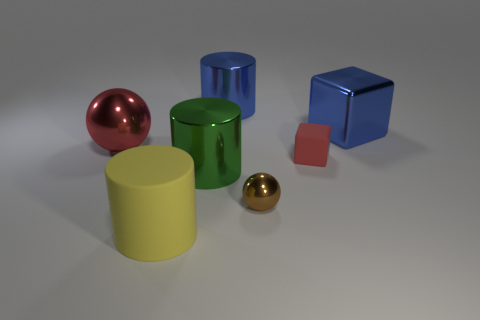What size is the other thing that is the same material as the tiny red thing?
Your answer should be compact. Large. What number of brown shiny things are the same shape as the large green thing?
Your answer should be very brief. 0. What number of red things are there?
Provide a succinct answer. 2. There is a red thing in front of the big metallic ball; is it the same shape as the large green thing?
Your answer should be very brief. No. Are there the same number of shiny blocks and large yellow metallic cylinders?
Make the answer very short. No. What is the material of the red sphere that is the same size as the blue block?
Keep it short and to the point. Metal. Are there any large gray blocks made of the same material as the tiny ball?
Provide a short and direct response. No. Do the tiny brown metallic thing and the green object that is in front of the red ball have the same shape?
Your response must be concise. No. How many metallic things are on the right side of the large green cylinder and on the left side of the red matte cube?
Your answer should be compact. 2. Is the large green cylinder made of the same material as the brown ball that is on the right side of the large yellow rubber cylinder?
Offer a terse response. Yes. 